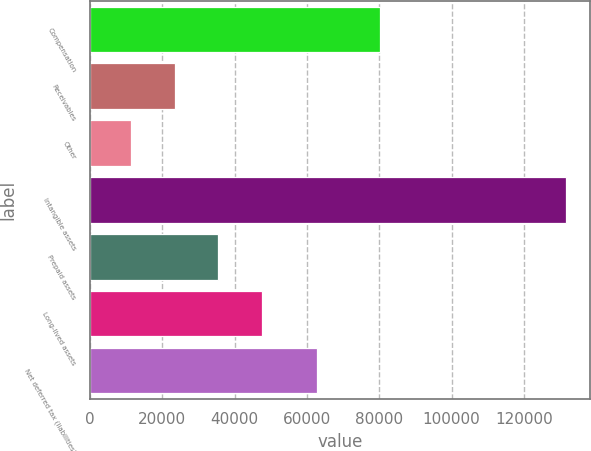Convert chart. <chart><loc_0><loc_0><loc_500><loc_500><bar_chart><fcel>Compensation<fcel>Receivables<fcel>Other<fcel>Intangible assets<fcel>Prepaid assets<fcel>Long-lived assets<fcel>Net deferred tax (liabilities)<nl><fcel>80338<fcel>23459.5<fcel>11433<fcel>131698<fcel>35486<fcel>47512.5<fcel>62872<nl></chart> 